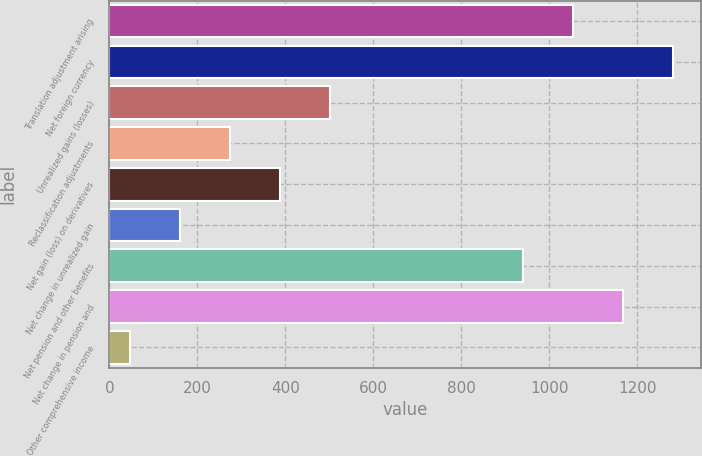Convert chart to OTSL. <chart><loc_0><loc_0><loc_500><loc_500><bar_chart><fcel>Translation adjustment arising<fcel>Net foreign currency<fcel>Unrealized gains (losses)<fcel>Reclassification adjustments<fcel>Net gain (loss) on derivatives<fcel>Net change in unrealized gain<fcel>Net pension and other benefits<fcel>Net change in pension and<fcel>Other comprehensive income<nl><fcel>1053.7<fcel>1281.1<fcel>501.8<fcel>274.4<fcel>388.1<fcel>160.7<fcel>940<fcel>1167.4<fcel>47<nl></chart> 